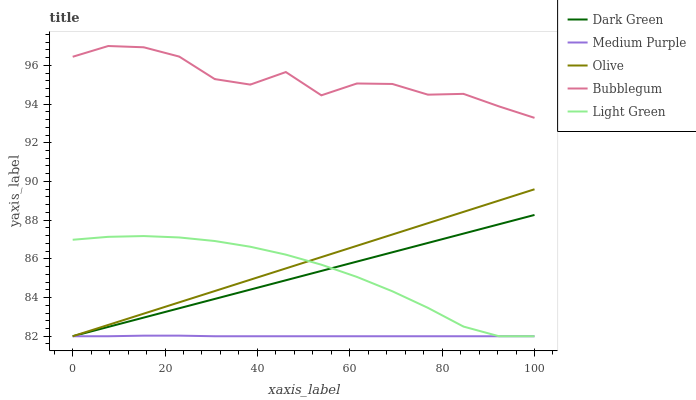Does Medium Purple have the minimum area under the curve?
Answer yes or no. Yes. Does Bubblegum have the maximum area under the curve?
Answer yes or no. Yes. Does Olive have the minimum area under the curve?
Answer yes or no. No. Does Olive have the maximum area under the curve?
Answer yes or no. No. Is Olive the smoothest?
Answer yes or no. Yes. Is Bubblegum the roughest?
Answer yes or no. Yes. Is Light Green the smoothest?
Answer yes or no. No. Is Light Green the roughest?
Answer yes or no. No. Does Medium Purple have the lowest value?
Answer yes or no. Yes. Does Bubblegum have the lowest value?
Answer yes or no. No. Does Bubblegum have the highest value?
Answer yes or no. Yes. Does Olive have the highest value?
Answer yes or no. No. Is Dark Green less than Bubblegum?
Answer yes or no. Yes. Is Bubblegum greater than Medium Purple?
Answer yes or no. Yes. Does Medium Purple intersect Dark Green?
Answer yes or no. Yes. Is Medium Purple less than Dark Green?
Answer yes or no. No. Is Medium Purple greater than Dark Green?
Answer yes or no. No. Does Dark Green intersect Bubblegum?
Answer yes or no. No. 